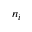<formula> <loc_0><loc_0><loc_500><loc_500>n _ { i }</formula> 